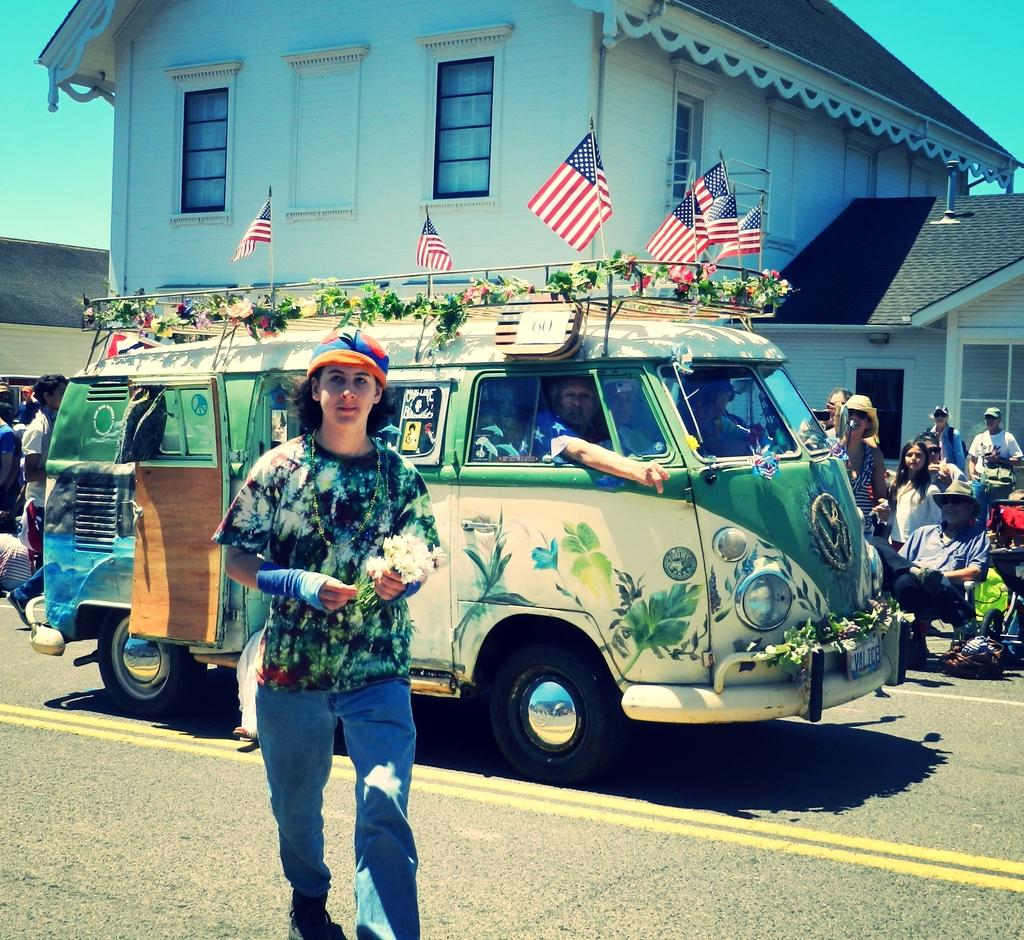What is the man in the image doing? The man in the image is walking on a road. What can be seen in the image besides the man walking? There is a vehicle with flags and a group of people in the image. What type of structure is visible in the image? There is a house in the image. How many yards of fabric are used to make the flags on the vehicle in the image? There is no information about the flags' fabric or the amount of fabric used in the image. 